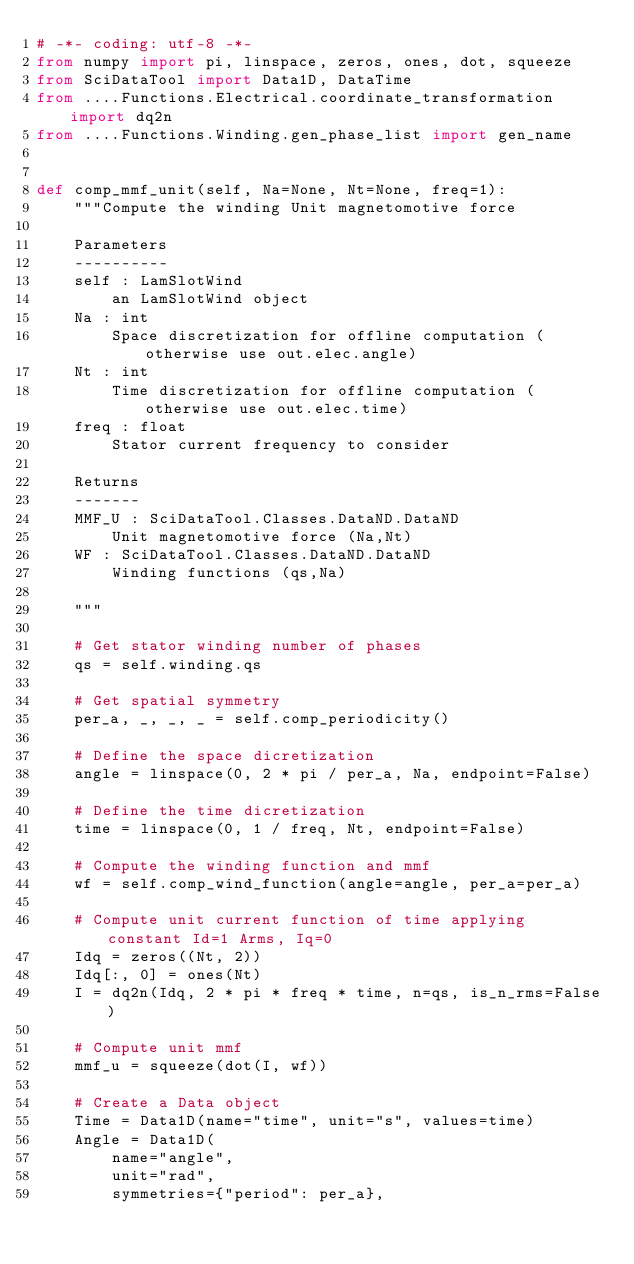Convert code to text. <code><loc_0><loc_0><loc_500><loc_500><_Python_># -*- coding: utf-8 -*-
from numpy import pi, linspace, zeros, ones, dot, squeeze
from SciDataTool import Data1D, DataTime
from ....Functions.Electrical.coordinate_transformation import dq2n
from ....Functions.Winding.gen_phase_list import gen_name


def comp_mmf_unit(self, Na=None, Nt=None, freq=1):
    """Compute the winding Unit magnetomotive force

    Parameters
    ----------
    self : LamSlotWind
        an LamSlotWind object
    Na : int
        Space discretization for offline computation (otherwise use out.elec.angle)
    Nt : int
        Time discretization for offline computation (otherwise use out.elec.time)
    freq : float
        Stator current frequency to consider

    Returns
    -------
    MMF_U : SciDataTool.Classes.DataND.DataND
        Unit magnetomotive force (Na,Nt)
    WF : SciDataTool.Classes.DataND.DataND
        Winding functions (qs,Na)

    """

    # Get stator winding number of phases
    qs = self.winding.qs

    # Get spatial symmetry
    per_a, _, _, _ = self.comp_periodicity()

    # Define the space dicretization
    angle = linspace(0, 2 * pi / per_a, Na, endpoint=False)

    # Define the time dicretization
    time = linspace(0, 1 / freq, Nt, endpoint=False)

    # Compute the winding function and mmf
    wf = self.comp_wind_function(angle=angle, per_a=per_a)

    # Compute unit current function of time applying constant Id=1 Arms, Iq=0
    Idq = zeros((Nt, 2))
    Idq[:, 0] = ones(Nt)
    I = dq2n(Idq, 2 * pi * freq * time, n=qs, is_n_rms=False)

    # Compute unit mmf
    mmf_u = squeeze(dot(I, wf))

    # Create a Data object
    Time = Data1D(name="time", unit="s", values=time)
    Angle = Data1D(
        name="angle",
        unit="rad",
        symmetries={"period": per_a},</code> 